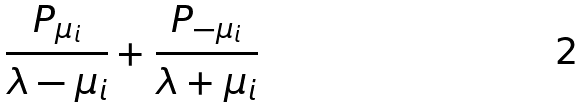<formula> <loc_0><loc_0><loc_500><loc_500>\frac { P _ { \mu _ { i } } } { \lambda - \mu _ { i } } + \frac { P _ { - \mu _ { i } } } { \lambda + \mu _ { i } }</formula> 